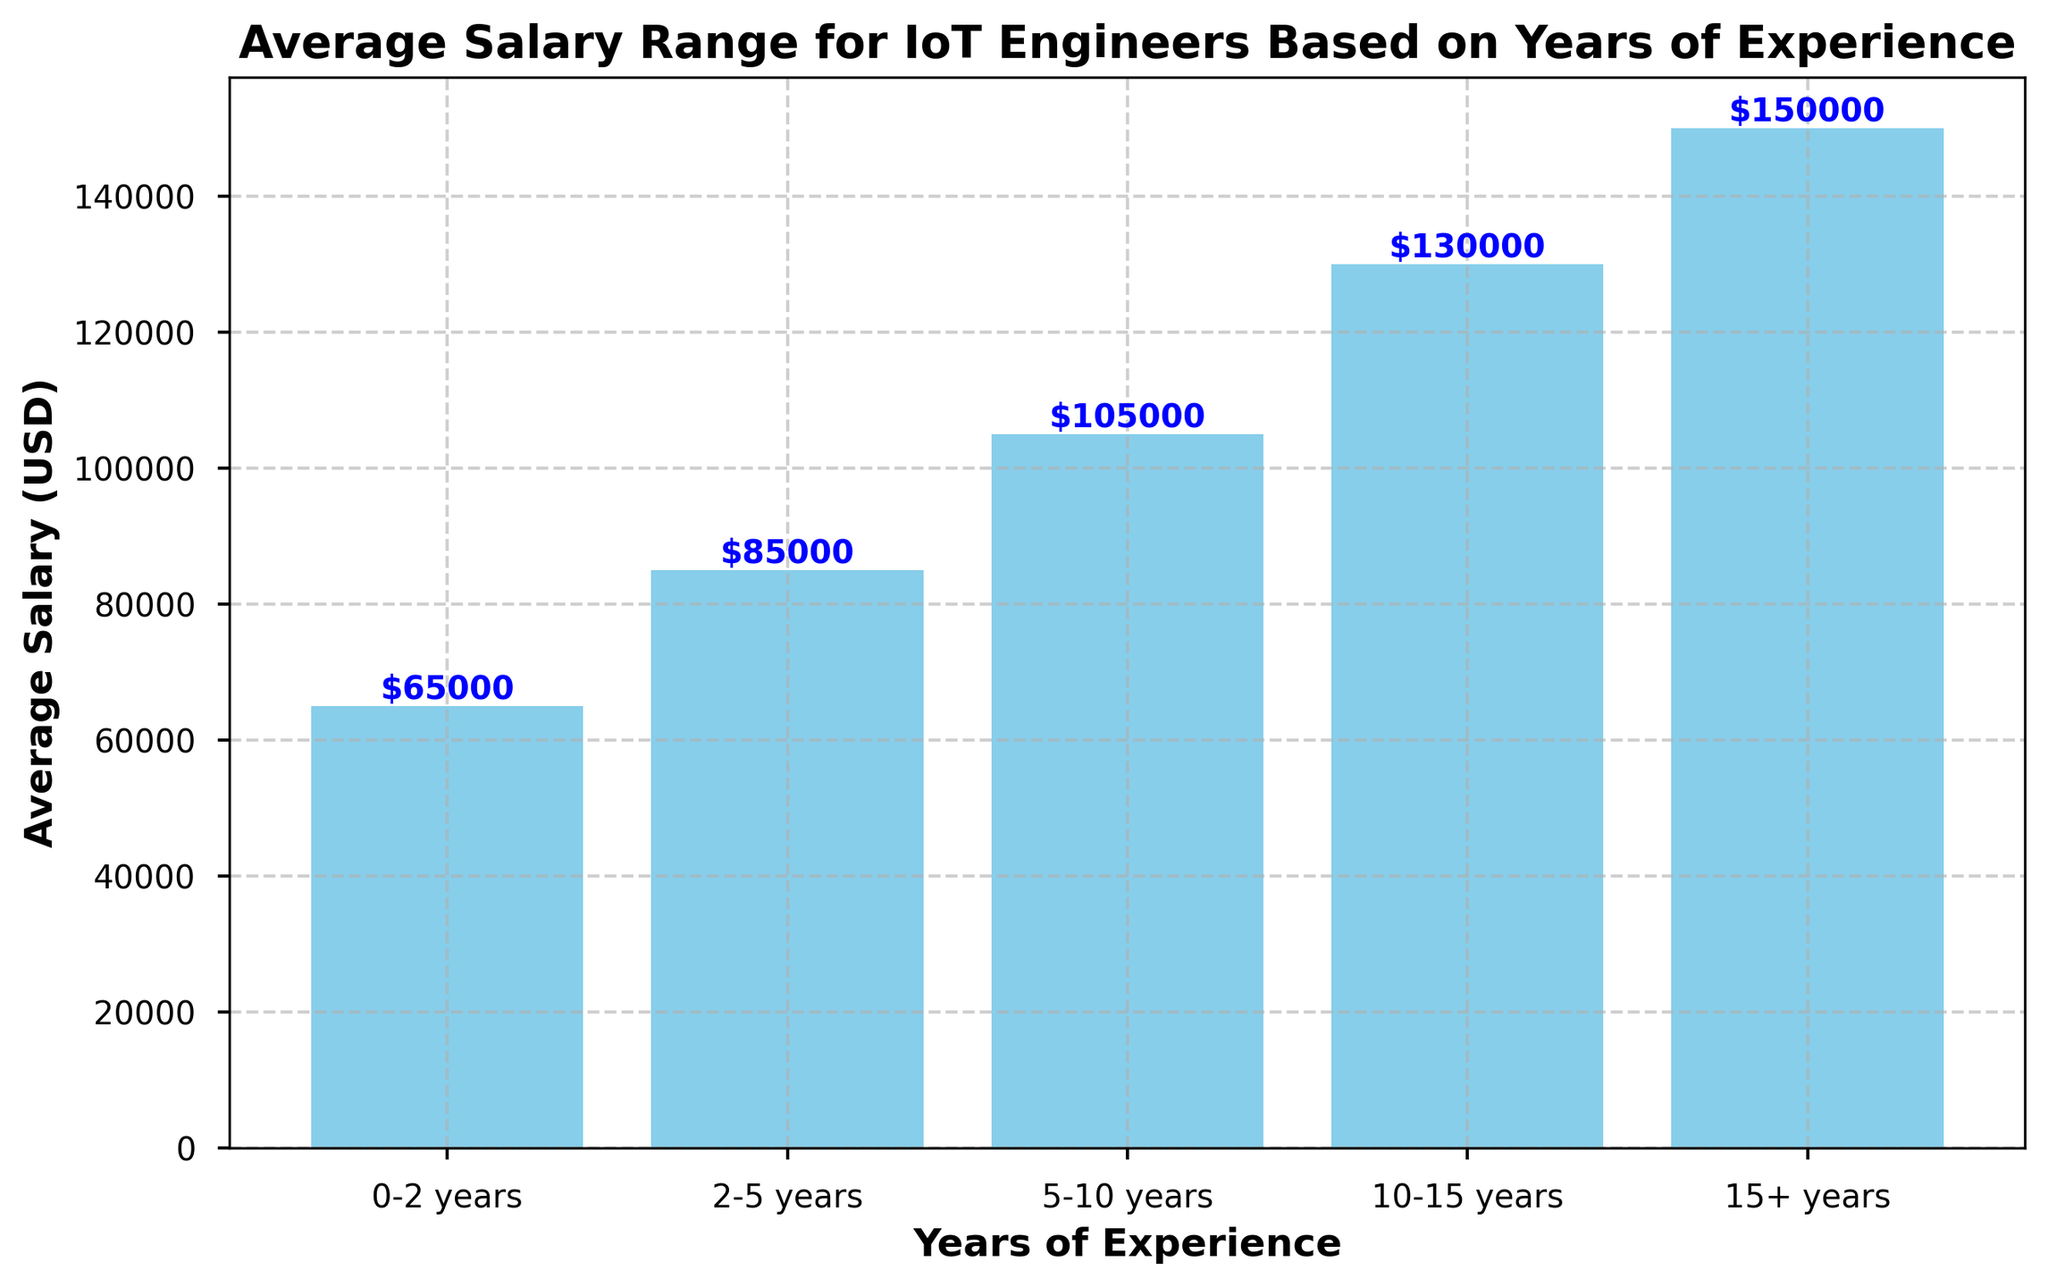What's the average salary for IoT engineers with 5-10 years of experience? Refer to the bar labeled '5-10 years' and check the height of the bar, which shows the average salary as $105,000.
Answer: $105,000 Which experience range has the highest average salary? Compare the heights of all bars; the tallest bar represents the highest salary. The '15+ years' bar is the tallest, indicating the highest salary.
Answer: 15+ years By how much does the average salary increase from 2-5 years to 10-15 years? Find the corresponding bars for '2-5 years' ($85,000) and '10-15 years' ($130,000) and calculate the difference: $130,000 - $85,000 = $45,000.
Answer: $45,000 Is there a larger salary increase from 0-2 years to 2-5 years or from 5-10 years to 10-15 years? Compare the increases: From 0-2 years ($65,000) to 2-5 years ($85,000) is $20,000; from 5-10 years ($105,000) to 10-15 years ($130,000) is $25,000.
Answer: 5-10 years to 10-15 years What is the total sum of average salaries for all experience ranges? Sum the heights of all bars: $65,000 + $85,000 + $105,000 + $130,000 + $150,000 = $535,000.
Answer: $535,000 How many experience ranges have an average salary below $100,000? Count the bars with heights less than $100,000: 0-2 years ($65,000) and 2-5 years ($85,000).
Answer: 2 By what percentage does the average salary increase from 0-2 years to 15+ years? Calculate the percentage increase: (($150,000 - $65,000) / $65,000) * 100% ≈ 130.77%.
Answer: ≈ 130.77% What is the difference in average salary between the least experienced group and the most experienced group? Subtract the smallest value from the largest: $150,000 (15+ years) - $65,000 (0-2 years) = $85,000.
Answer: $85,000 What is the median average salary range of IoT engineers based on the years of experience? Arrange the average salaries in ascending order: $65,000, $85,000, $105,000, $130,000, $150,000. The middle value is $105,000.
Answer: $105,000 